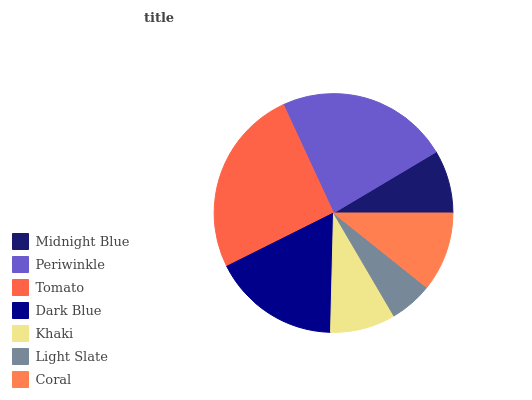Is Light Slate the minimum?
Answer yes or no. Yes. Is Tomato the maximum?
Answer yes or no. Yes. Is Periwinkle the minimum?
Answer yes or no. No. Is Periwinkle the maximum?
Answer yes or no. No. Is Periwinkle greater than Midnight Blue?
Answer yes or no. Yes. Is Midnight Blue less than Periwinkle?
Answer yes or no. Yes. Is Midnight Blue greater than Periwinkle?
Answer yes or no. No. Is Periwinkle less than Midnight Blue?
Answer yes or no. No. Is Coral the high median?
Answer yes or no. Yes. Is Coral the low median?
Answer yes or no. Yes. Is Tomato the high median?
Answer yes or no. No. Is Dark Blue the low median?
Answer yes or no. No. 